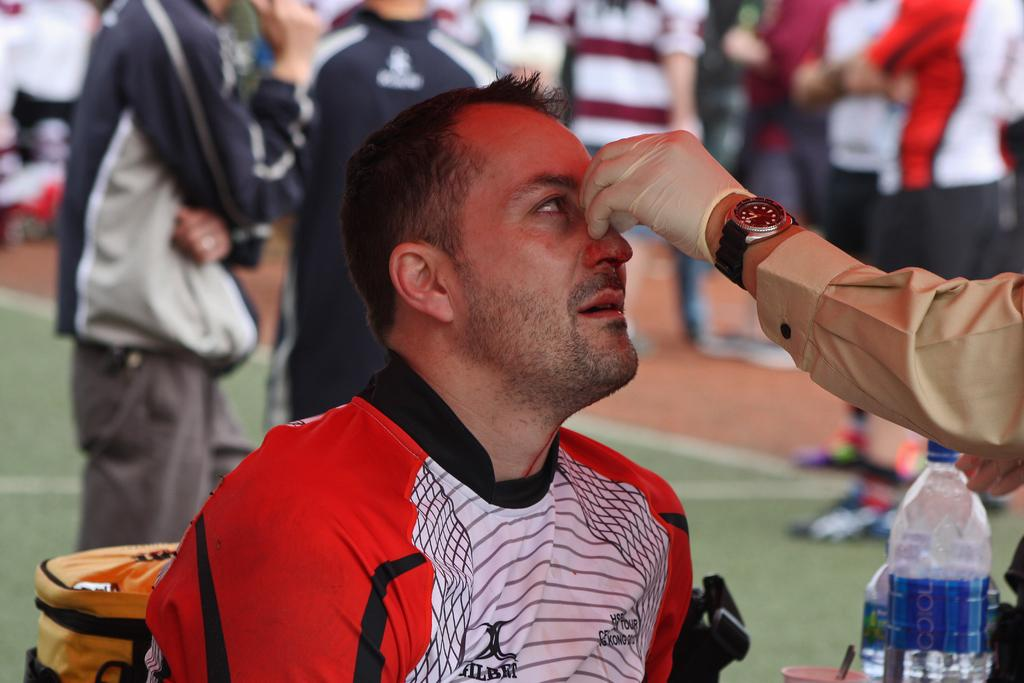What is the person in the image doing? The person is sitting on a chair in the image. What object is in front of the person? There is a water bottle in front of the person. Can you describe the people in the background of the image? There are people standing on the floor in the background of the image. What type of insurance does the person sitting on the chair have? There is no information about insurance in the image, as it focuses on the person sitting on a chair and the surrounding environment. 